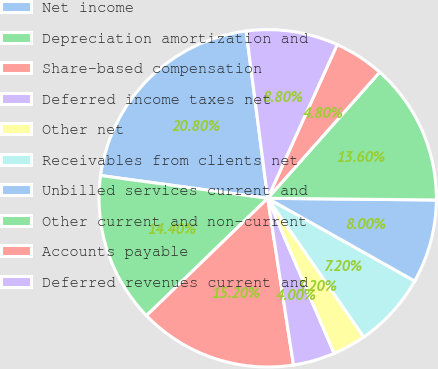Convert chart. <chart><loc_0><loc_0><loc_500><loc_500><pie_chart><fcel>Net income<fcel>Depreciation amortization and<fcel>Share-based compensation<fcel>Deferred income taxes net<fcel>Other net<fcel>Receivables from clients net<fcel>Unbilled services current and<fcel>Other current and non-current<fcel>Accounts payable<fcel>Deferred revenues current and<nl><fcel>20.8%<fcel>14.4%<fcel>15.2%<fcel>4.0%<fcel>3.2%<fcel>7.2%<fcel>8.0%<fcel>13.6%<fcel>4.8%<fcel>8.8%<nl></chart> 